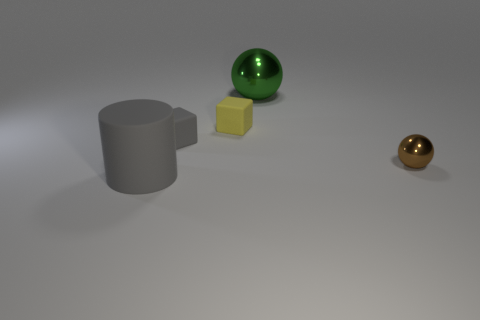Are there any other things that are the same shape as the big matte thing?
Keep it short and to the point. No. Is there any other thing that is the same size as the gray rubber cylinder?
Provide a short and direct response. Yes. There is a cylinder that is the same material as the tiny yellow block; what color is it?
Offer a terse response. Gray. The metallic object behind the brown thing is what color?
Make the answer very short. Green. What number of things are the same color as the large cylinder?
Your response must be concise. 1. Are there fewer small matte cubes that are in front of the small gray block than small objects right of the yellow matte block?
Ensure brevity in your answer.  Yes. There is a small gray matte thing; how many shiny spheres are behind it?
Provide a short and direct response. 1. Is there a small gray thing made of the same material as the green thing?
Your answer should be compact. No. Is the number of green objects that are to the right of the small ball greater than the number of small rubber blocks on the right side of the green object?
Provide a short and direct response. No. What is the size of the yellow matte cube?
Your answer should be very brief. Small. 